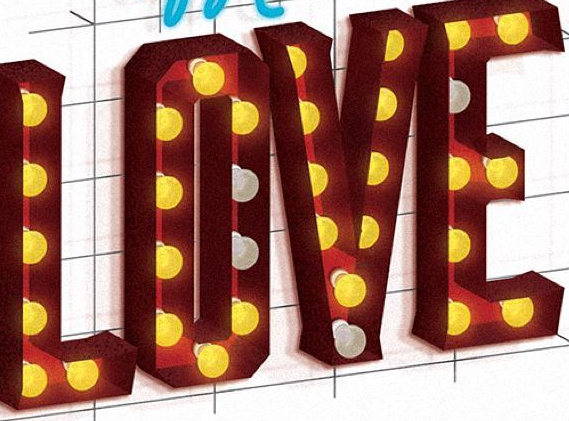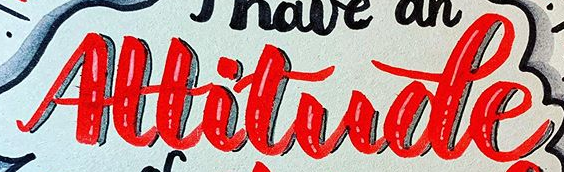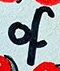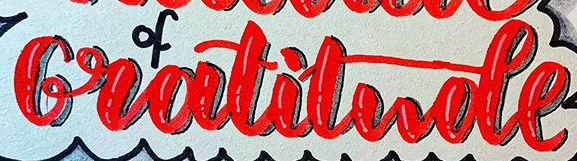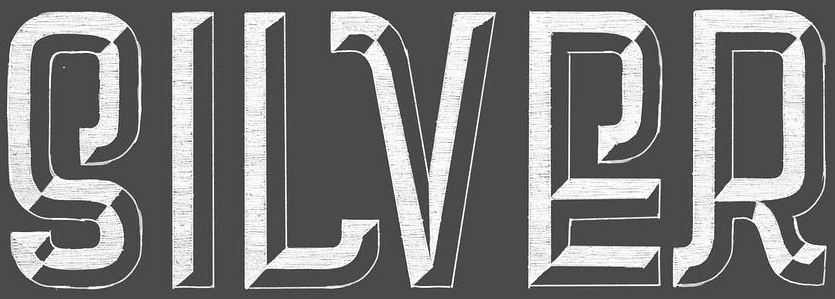What text is displayed in these images sequentially, separated by a semicolon? LOVE; Altitude; of; Gratitude; SILVER 